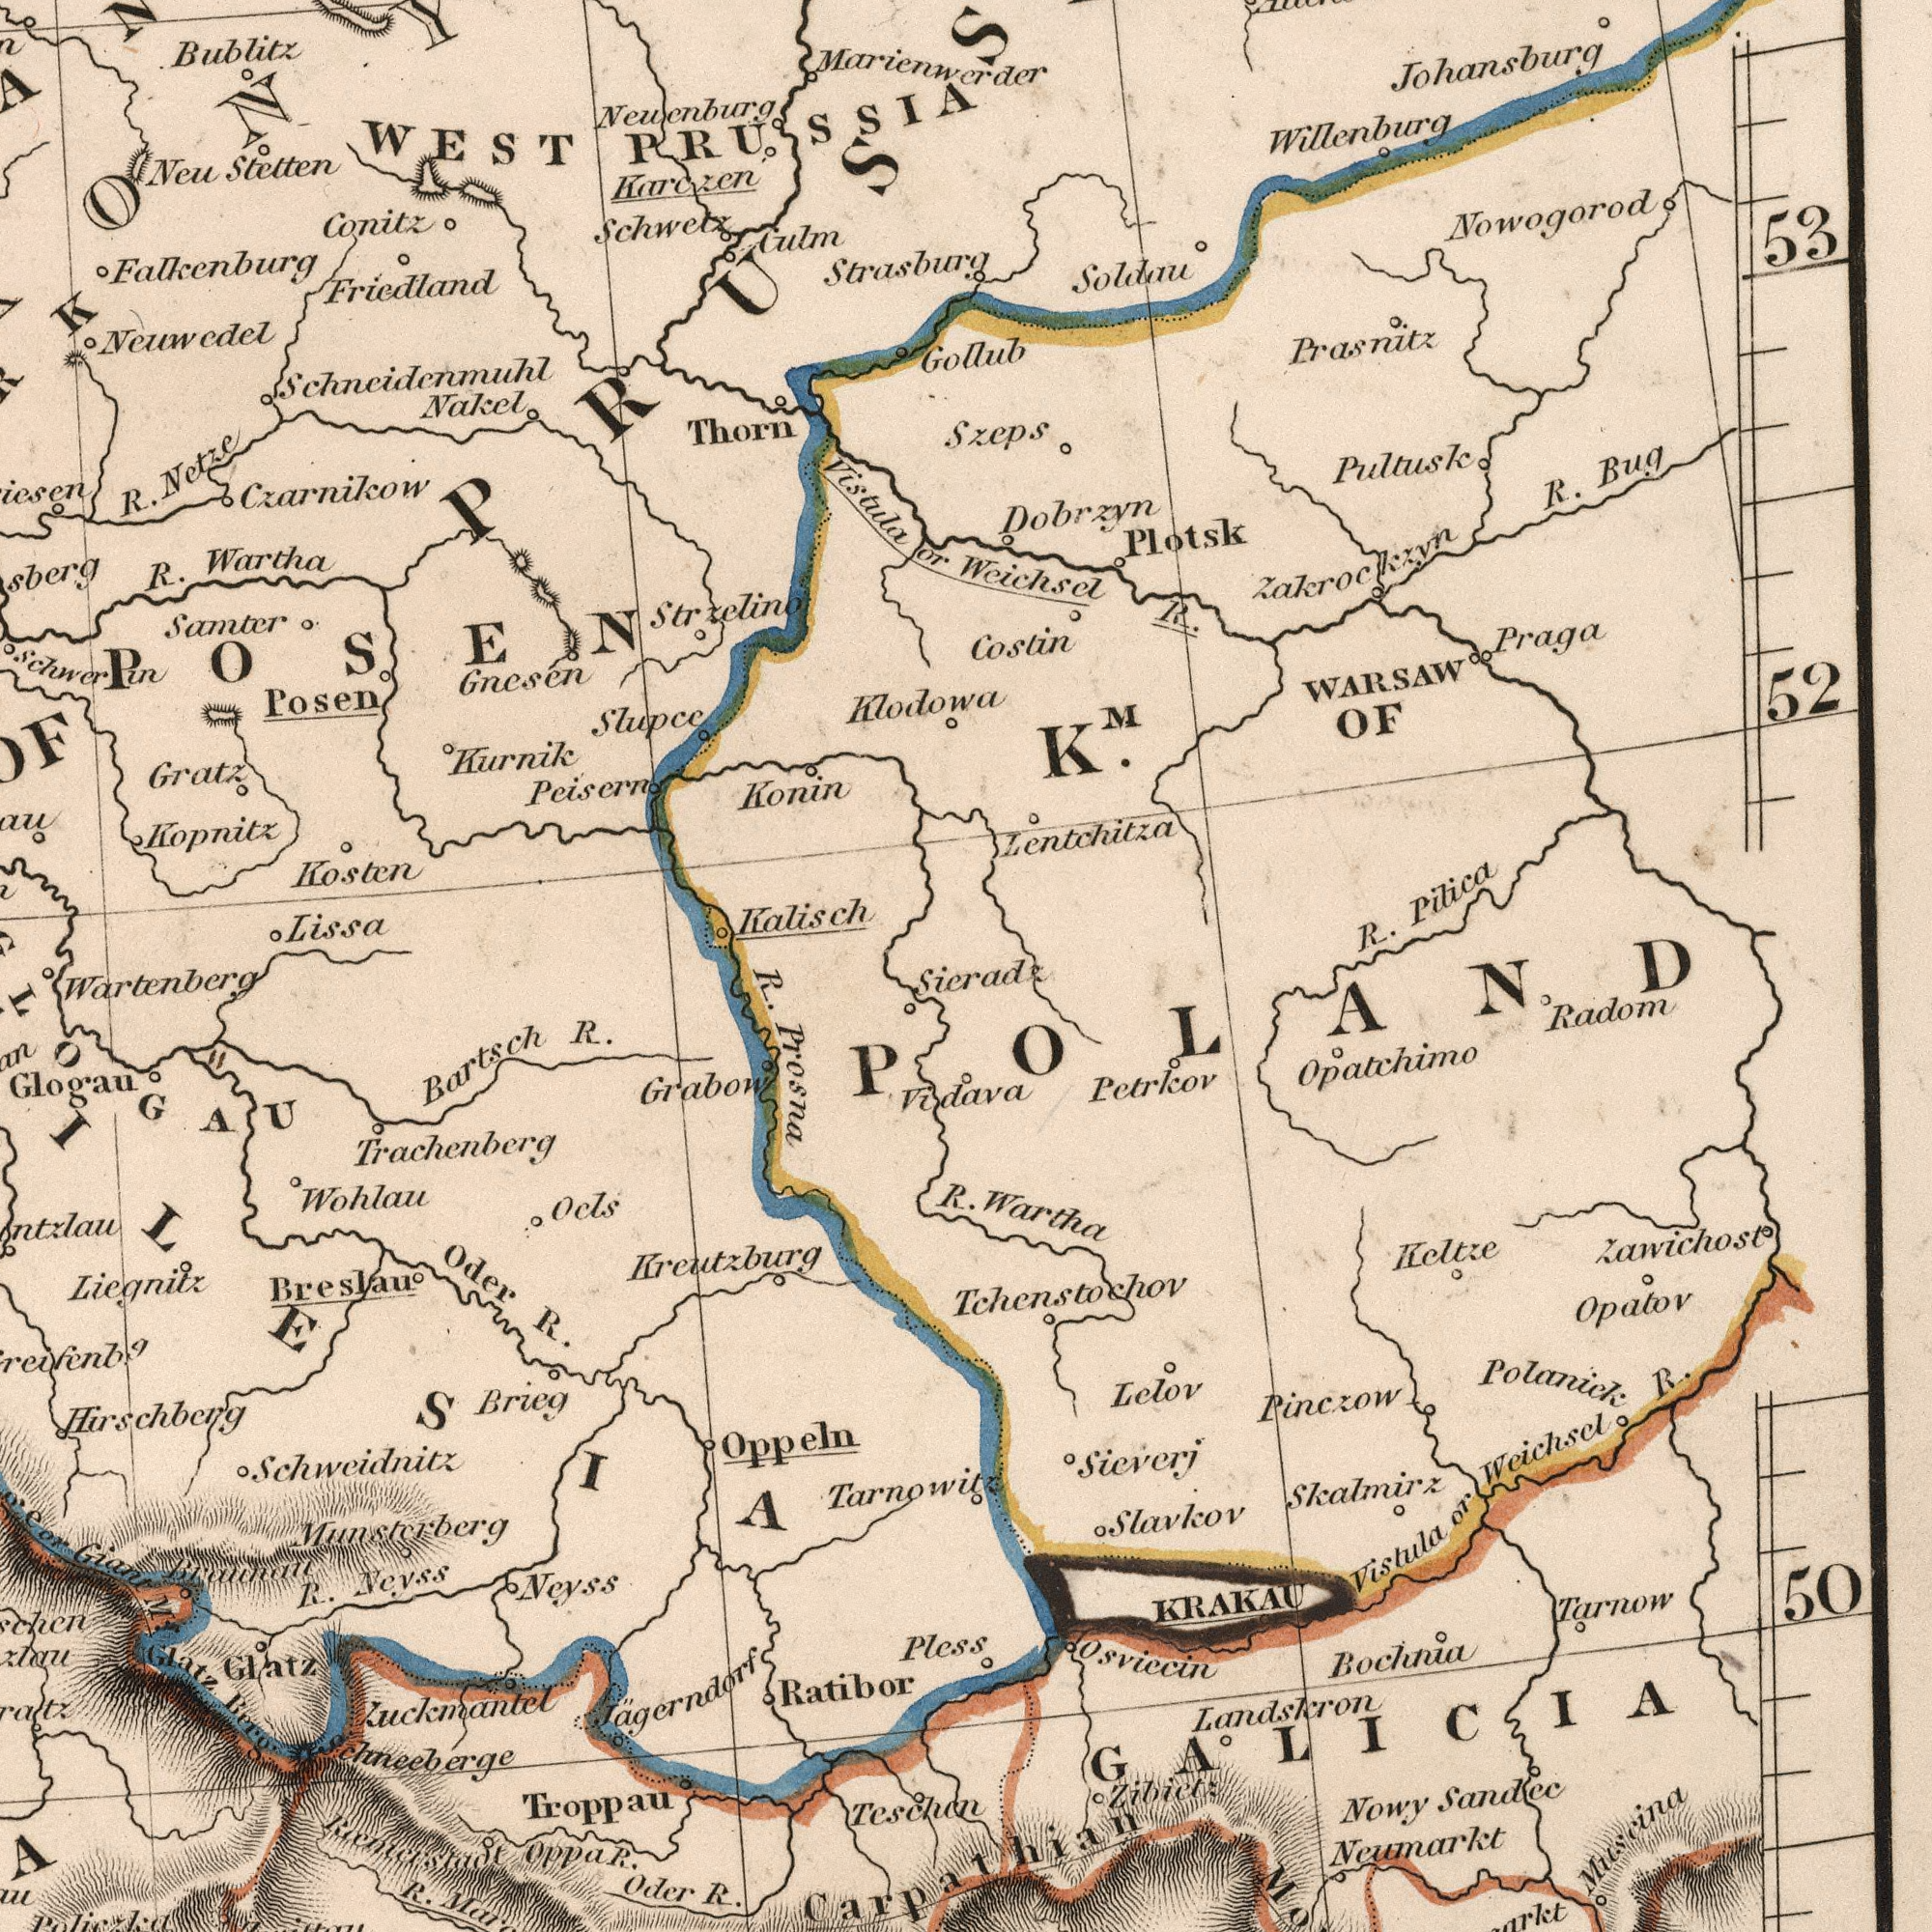What text is shown in the top-right quadrant? Weichsel R. Nowogorod Lentchitza Dobrzyn Plotsk R. Bug Coslin Johansburg Prasnitz Praga OF Pultusk Soldau WARSAW R. Pilica Zakrockzyn GoIlub Willenburg 52 53 Szeps KM. Sieradz What text can you see in the bottom-right section? R Wartha Pless Vidava Opatchimo Skalmirz Nowy Sandec Bochnia Radom Petrkov KRAKAU Vistula or Weichscl R. Zibietz Lelov Zawichost Slavkov Keltze Tarnow Polanick Opatov Pinczow Osviccin Neunarkt Landskron Muscina Tchenstochov 50 Sieverj Carpathian GALICIA POLAND What text is shown in the top-left quadrant? Friedland Falkenburg Marienwerder Lissa Neuwedel Kurnik Posen Bublitz Nakel Samter Thorn Kopnitz Neu Stetten Gnesen Peisern Conitz Schwetz R. Netze WEST PRU SSIA R. Wartha Klodowa Gratz Neuenburg Strzelino Vistula or Czarnikow Kosten Culm Konin Schneidenmuhl Schwerin Kalisch Karczen Strasburg Slupce POSEN What text is shown in the bottom-left quadrant? R. Prosna Zuckmantel Oder R. Glatz Braunau Oder R. Grabow Bartsch R. Neyss R. Troppau Giant Glatz Berg Ocls Jagerndorf Schweidnitz Munsterberg Wohlau Teschen R. Neyss Ratibor Ranurstadt Oppa R. Hirschberg Jchneeberge Tarnowitz Liegnitz Glogau Wartenberg Breslau Kreutzburg Trachenberg Brieg Oppeln ILESIA Policzka 